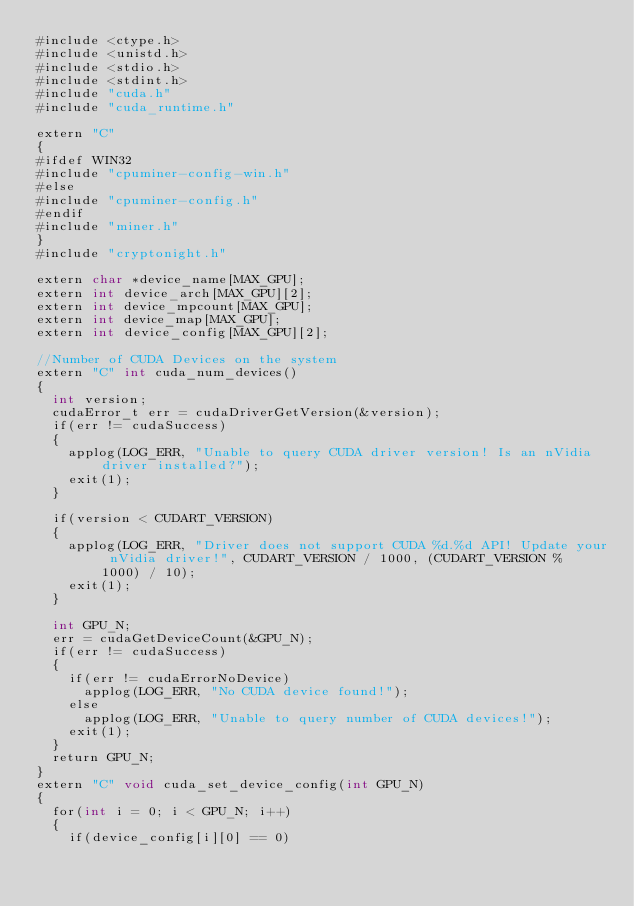Convert code to text. <code><loc_0><loc_0><loc_500><loc_500><_Cuda_>#include <ctype.h>
#include <unistd.h>
#include <stdio.h>
#include <stdint.h>
#include "cuda.h"
#include "cuda_runtime.h"

extern "C"
{
#ifdef WIN32
#include "cpuminer-config-win.h"
#else
#include "cpuminer-config.h"
#endif
#include "miner.h"
}
#include "cryptonight.h"

extern char *device_name[MAX_GPU];
extern int device_arch[MAX_GPU][2];
extern int device_mpcount[MAX_GPU];
extern int device_map[MAX_GPU];
extern int device_config[MAX_GPU][2];

//Number of CUDA Devices on the system
extern "C" int cuda_num_devices()
{
	int version;
	cudaError_t err = cudaDriverGetVersion(&version);
	if(err != cudaSuccess)
	{
		applog(LOG_ERR, "Unable to query CUDA driver version! Is an nVidia driver installed?");
		exit(1);
	}

	if(version < CUDART_VERSION)
	{
		applog(LOG_ERR, "Driver does not support CUDA %d.%d API! Update your nVidia driver!", CUDART_VERSION / 1000, (CUDART_VERSION % 1000) / 10);
		exit(1);
	}

	int GPU_N;
	err = cudaGetDeviceCount(&GPU_N);
	if(err != cudaSuccess)
	{
		if(err != cudaErrorNoDevice)
			applog(LOG_ERR, "No CUDA device found!");
		else
			applog(LOG_ERR, "Unable to query number of CUDA devices!");
		exit(1);
	}
	return GPU_N;
}
extern "C" void cuda_set_device_config(int GPU_N)
{
	for(int i = 0; i < GPU_N; i++)
	{
		if(device_config[i][0] == 0)</code> 